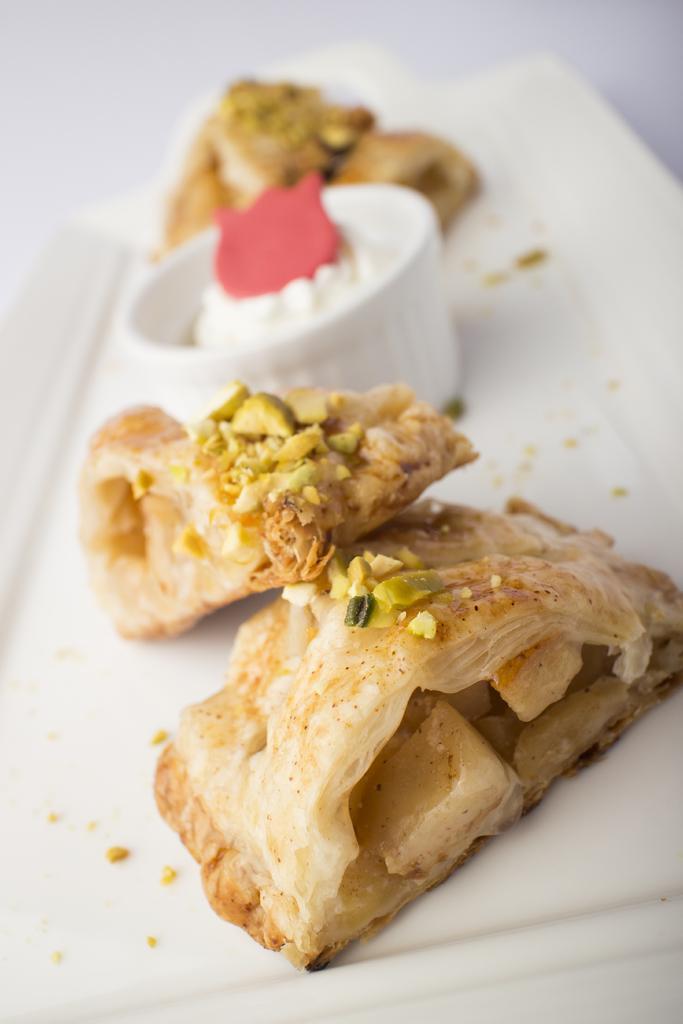Could you give a brief overview of what you see in this image? In the picture we can see some food item which is in white color tray. 